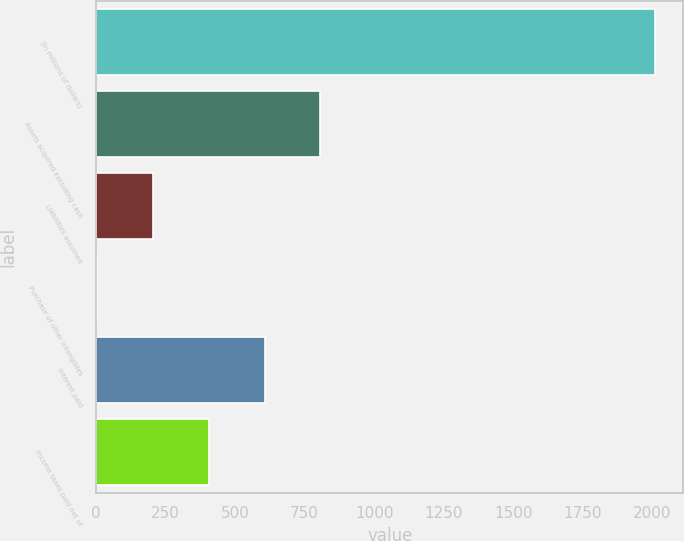Convert chart to OTSL. <chart><loc_0><loc_0><loc_500><loc_500><bar_chart><fcel>(In millions of dollars)<fcel>Assets acquired excluding cash<fcel>Liabilities assumed<fcel>Purchase of other intangibles<fcel>Interest paid<fcel>Income taxes paid net of<nl><fcel>2011<fcel>806.8<fcel>204.7<fcel>4<fcel>606.1<fcel>405.4<nl></chart> 